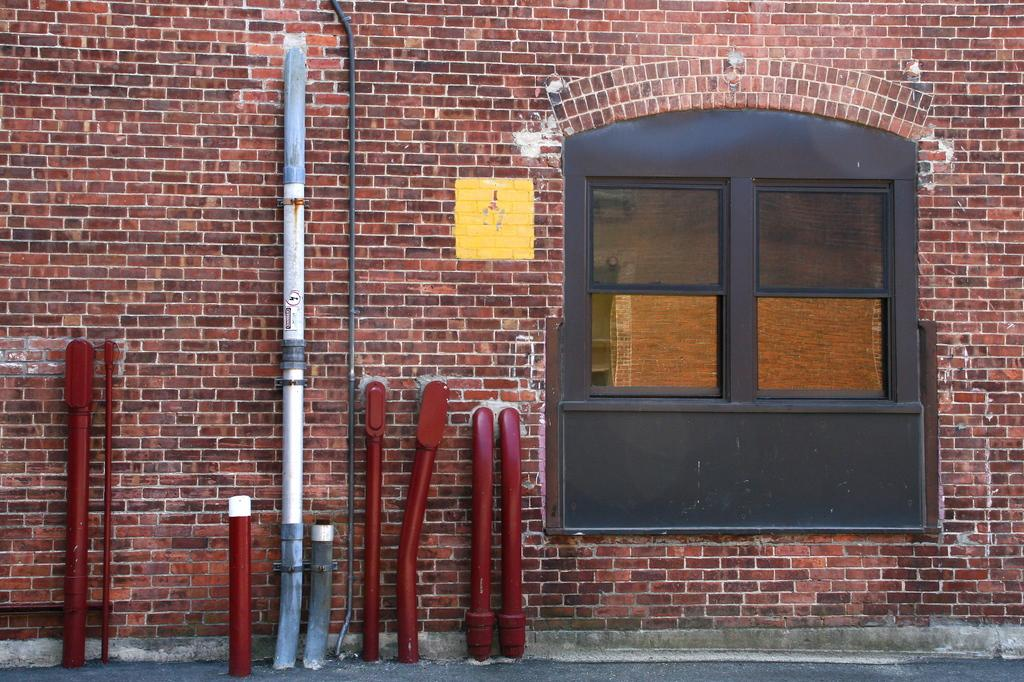What can be seen in the image? There are objects in the image. What architectural feature is present in the image? There is a window in the image. What else can be seen in the image besides the window? There is a wall in the image. How many cherries are on the servant's tray in the image? There is no servant or tray with cherries present in the image. 